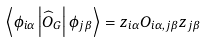<formula> <loc_0><loc_0><loc_500><loc_500>\left \langle \phi _ { i \alpha } \left | \widehat { O } _ { G } \right | \phi _ { j \beta } \right \rangle = z _ { i \alpha } O _ { i \alpha , j \beta } z _ { j \beta }</formula> 